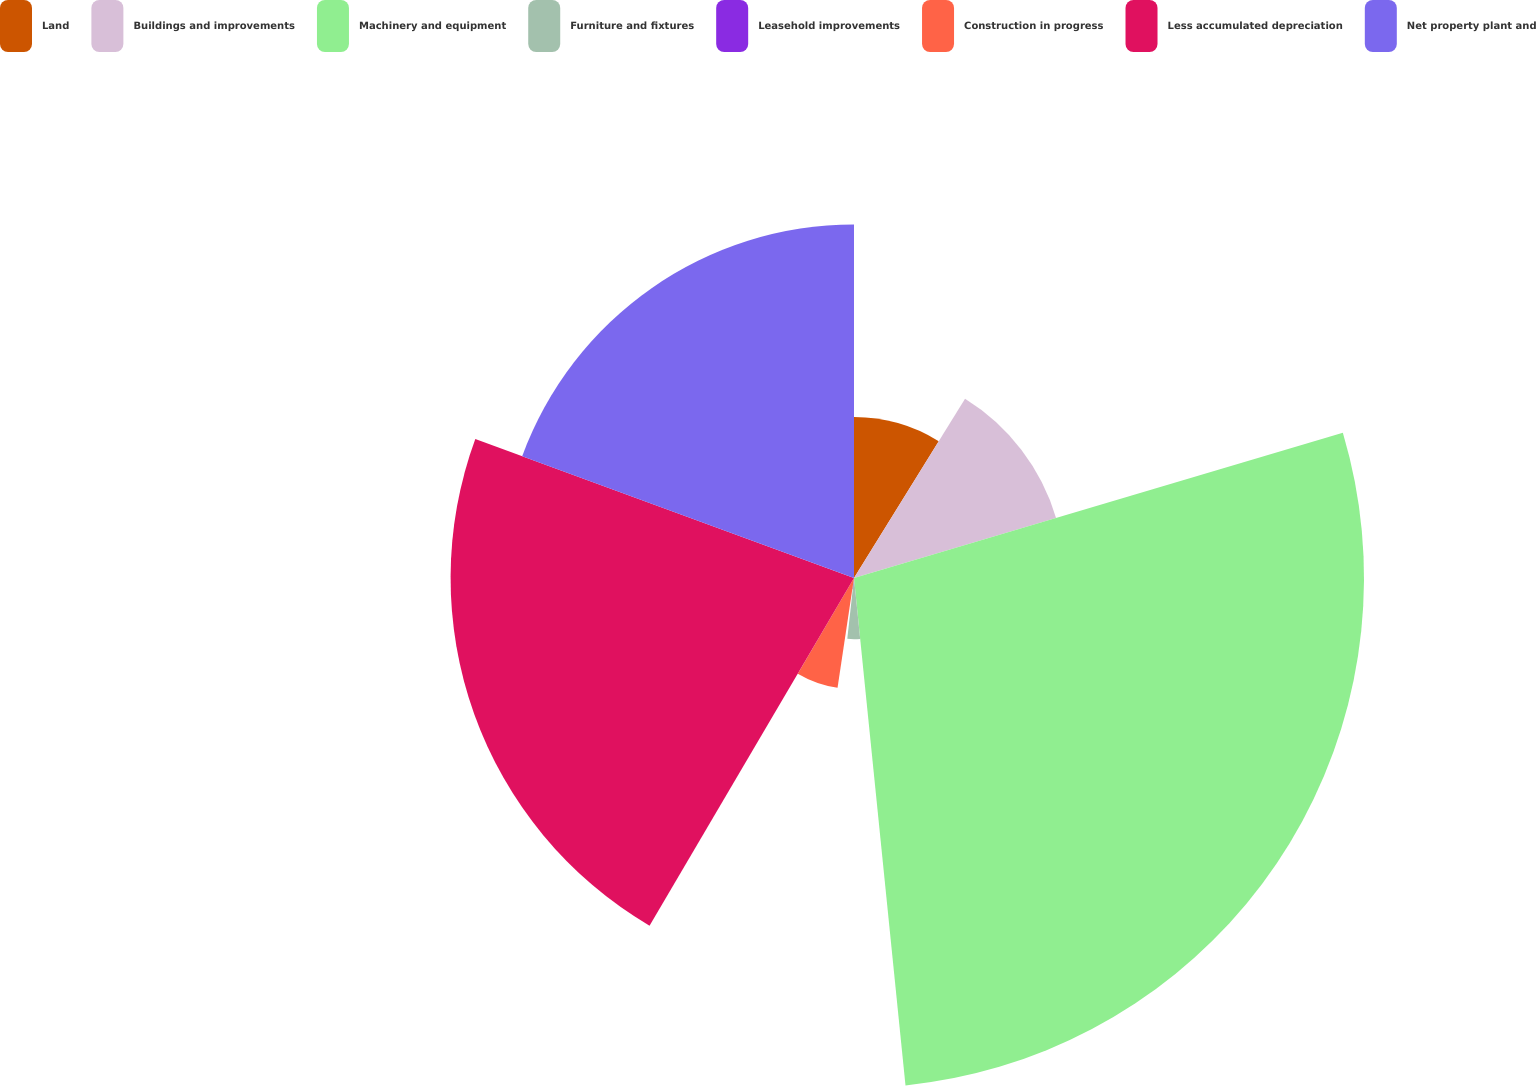Convert chart to OTSL. <chart><loc_0><loc_0><loc_500><loc_500><pie_chart><fcel>Land<fcel>Buildings and improvements<fcel>Machinery and equipment<fcel>Furniture and fixtures<fcel>Leasehold improvements<fcel>Construction in progress<fcel>Less accumulated depreciation<fcel>Net property plant and<nl><fcel>8.83%<fcel>11.57%<fcel>27.99%<fcel>3.36%<fcel>0.62%<fcel>6.09%<fcel>22.14%<fcel>19.4%<nl></chart> 